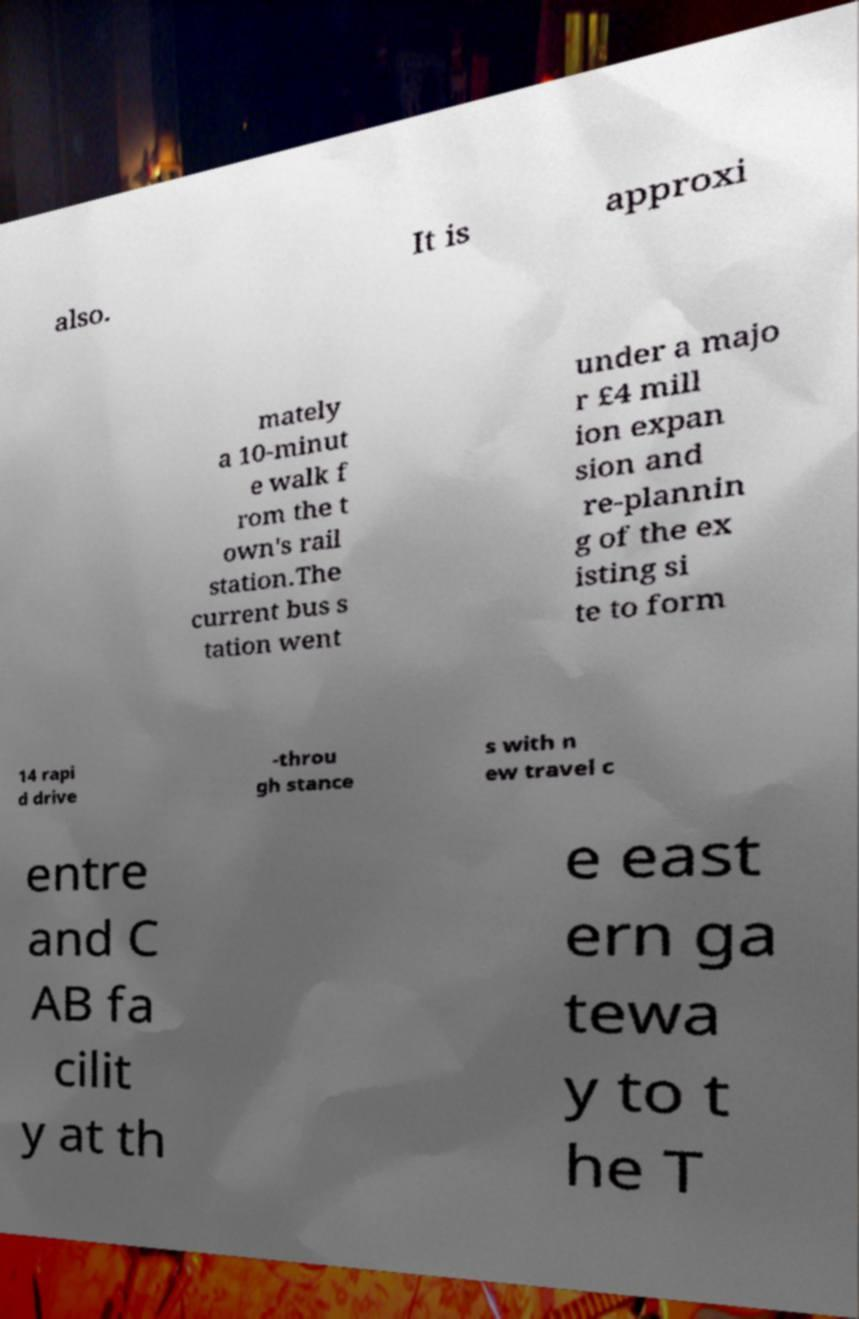What messages or text are displayed in this image? I need them in a readable, typed format. also. It is approxi mately a 10-minut e walk f rom the t own's rail station.The current bus s tation went under a majo r £4 mill ion expan sion and re-plannin g of the ex isting si te to form 14 rapi d drive -throu gh stance s with n ew travel c entre and C AB fa cilit y at th e east ern ga tewa y to t he T 